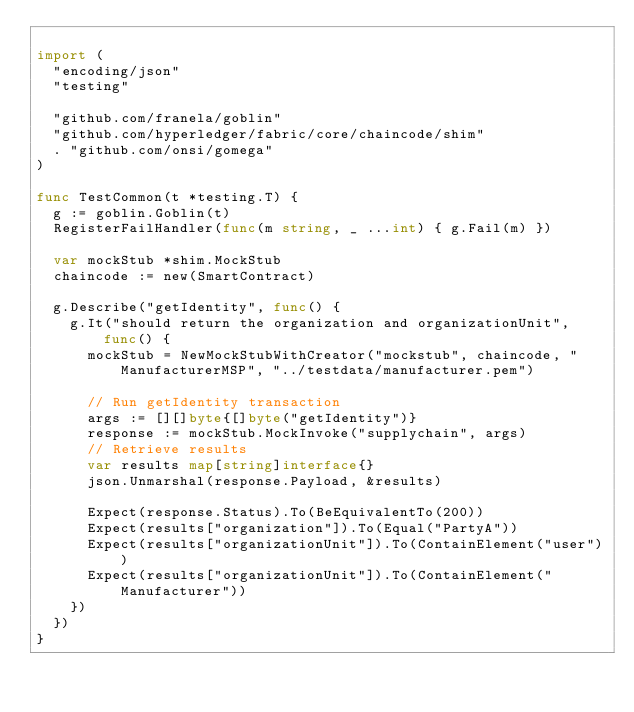<code> <loc_0><loc_0><loc_500><loc_500><_Go_>
import (
	"encoding/json"
	"testing"

	"github.com/franela/goblin"
	"github.com/hyperledger/fabric/core/chaincode/shim"
	. "github.com/onsi/gomega"
)

func TestCommon(t *testing.T) {
	g := goblin.Goblin(t)
	RegisterFailHandler(func(m string, _ ...int) { g.Fail(m) })

	var mockStub *shim.MockStub
	chaincode := new(SmartContract)

	g.Describe("getIdentity", func() {
		g.It("should return the organization and organizationUnit", func() {
			mockStub = NewMockStubWithCreator("mockstub", chaincode, "ManufacturerMSP", "../testdata/manufacturer.pem")

			// Run getIdentity transaction
			args := [][]byte{[]byte("getIdentity")}
			response := mockStub.MockInvoke("supplychain", args)
			// Retrieve results
			var results map[string]interface{}
			json.Unmarshal(response.Payload, &results)

			Expect(response.Status).To(BeEquivalentTo(200))
			Expect(results["organization"]).To(Equal("PartyA"))
			Expect(results["organizationUnit"]).To(ContainElement("user"))
			Expect(results["organizationUnit"]).To(ContainElement("Manufacturer"))
		})
	})
}
</code> 